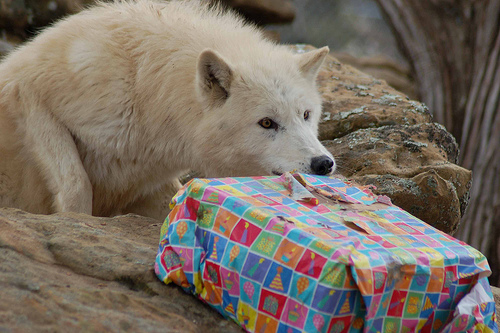<image>
Is the wolf behind the present? Yes. From this viewpoint, the wolf is positioned behind the present, with the present partially or fully occluding the wolf. 